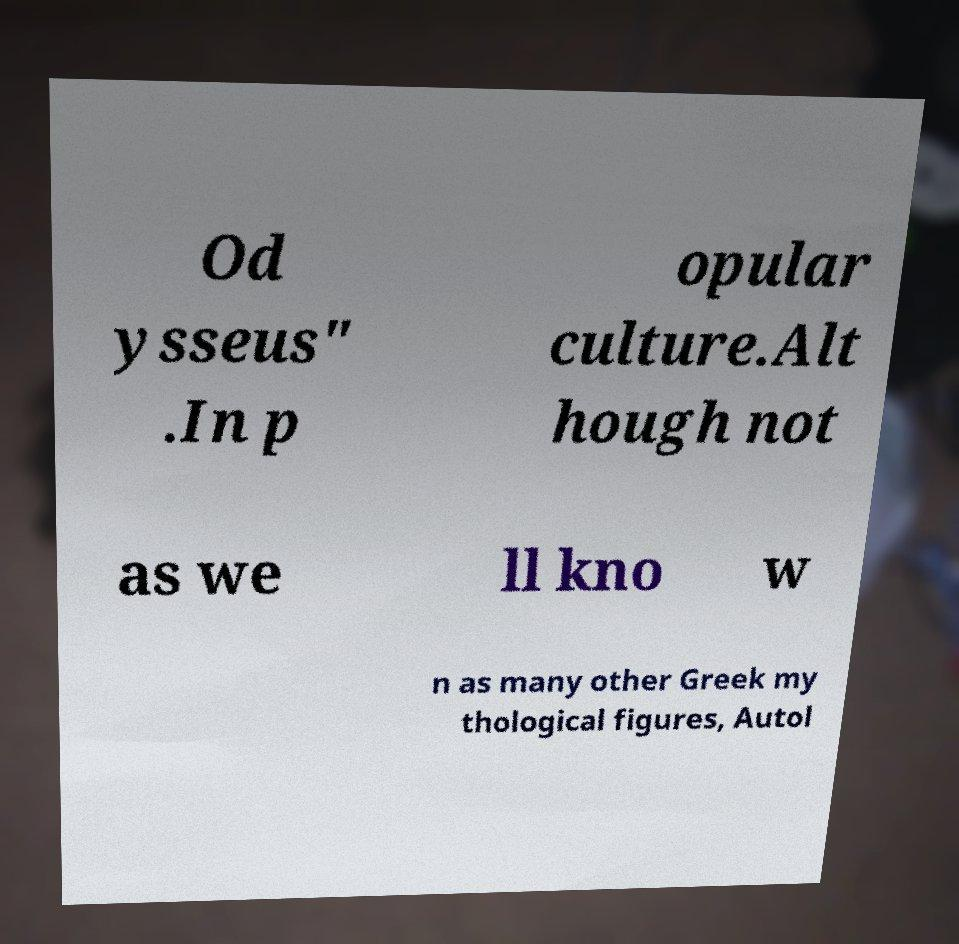There's text embedded in this image that I need extracted. Can you transcribe it verbatim? Od ysseus" .In p opular culture.Alt hough not as we ll kno w n as many other Greek my thological figures, Autol 